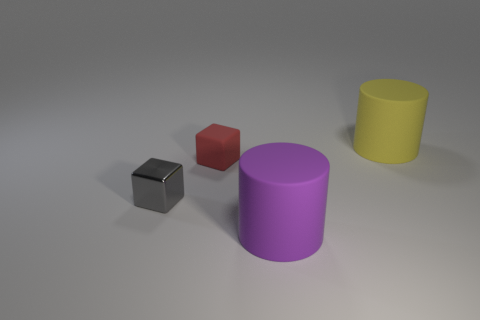Is the number of shiny cubes greater than the number of blocks?
Give a very brief answer. No. How many things are either rubber cylinders behind the large purple matte object or tiny purple shiny objects?
Your answer should be very brief. 1. What number of big rubber cylinders are on the right side of the matte object on the right side of the purple rubber cylinder?
Your answer should be compact. 0. What size is the thing that is to the right of the big cylinder left of the cylinder that is behind the tiny rubber block?
Ensure brevity in your answer.  Large. What is the size of the other rubber object that is the same shape as the yellow matte object?
Offer a terse response. Large. How many things are either matte cylinders behind the gray metal block or matte things in front of the yellow cylinder?
Make the answer very short. 3. What is the shape of the large object to the left of the large cylinder that is on the right side of the purple thing?
Your response must be concise. Cylinder. What number of things are small matte cubes or gray metallic objects?
Your answer should be very brief. 2. Is there another red cube that has the same size as the shiny cube?
Keep it short and to the point. Yes. What is the shape of the gray metallic object?
Keep it short and to the point. Cube. 